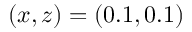Convert formula to latex. <formula><loc_0><loc_0><loc_500><loc_500>( x , z ) = ( 0 . 1 , 0 . 1 )</formula> 